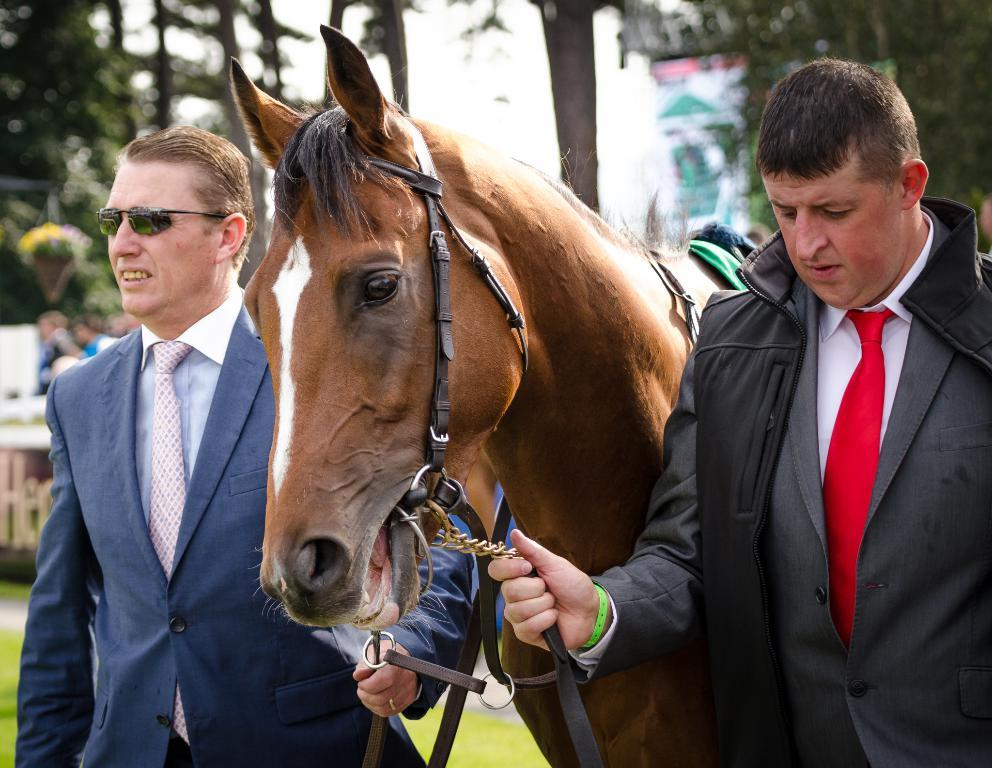What type of plant can be seen in the image? There is a tree in the image. How many people are present in the image? There are two people in the image. What animal is also visible in the image? There is a horse in the image. What type of ice can be seen melting on the horse's back in the image? There is no ice present in the image, and therefore no ice can be seen melting on the horse's back. 